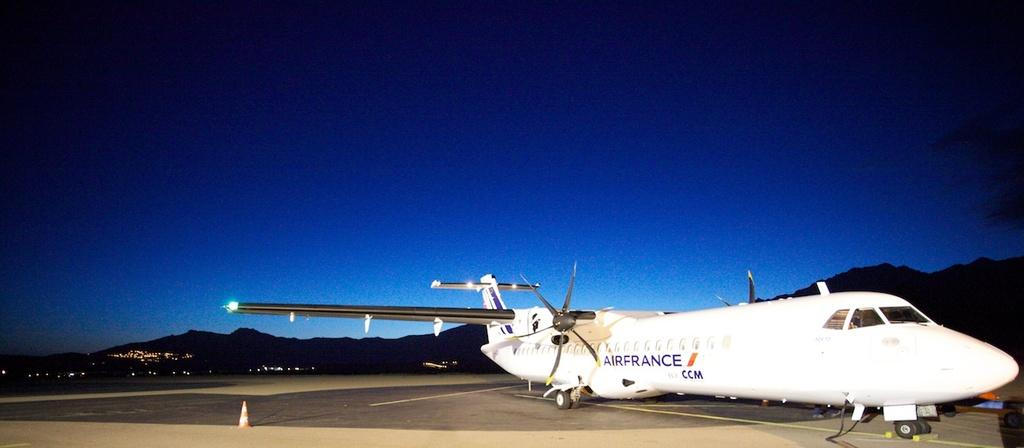<image>
Present a compact description of the photo's key features. A white AIRFRANCE airplane is on a runway at night. 